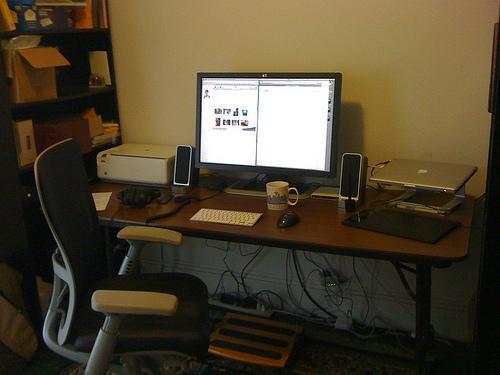How many speakers are there?
Give a very brief answer. 2. 